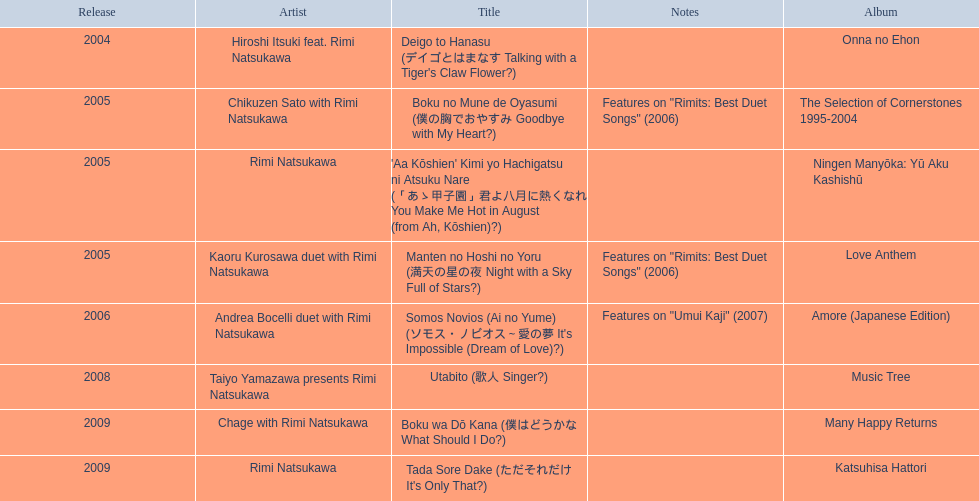Which title of the rimi natsukawa discography was released in the 2004? Deigo to Hanasu (デイゴとはまなす Talking with a Tiger's Claw Flower?). Which title has notes that features on/rimits. best duet songs\2006 Manten no Hoshi no Yoru (満天の星の夜 Night with a Sky Full of Stars?). Which title share the same notes as night with a sky full of stars? Boku no Mune de Oyasumi (僕の胸でおやすみ Goodbye with My Heart?). 